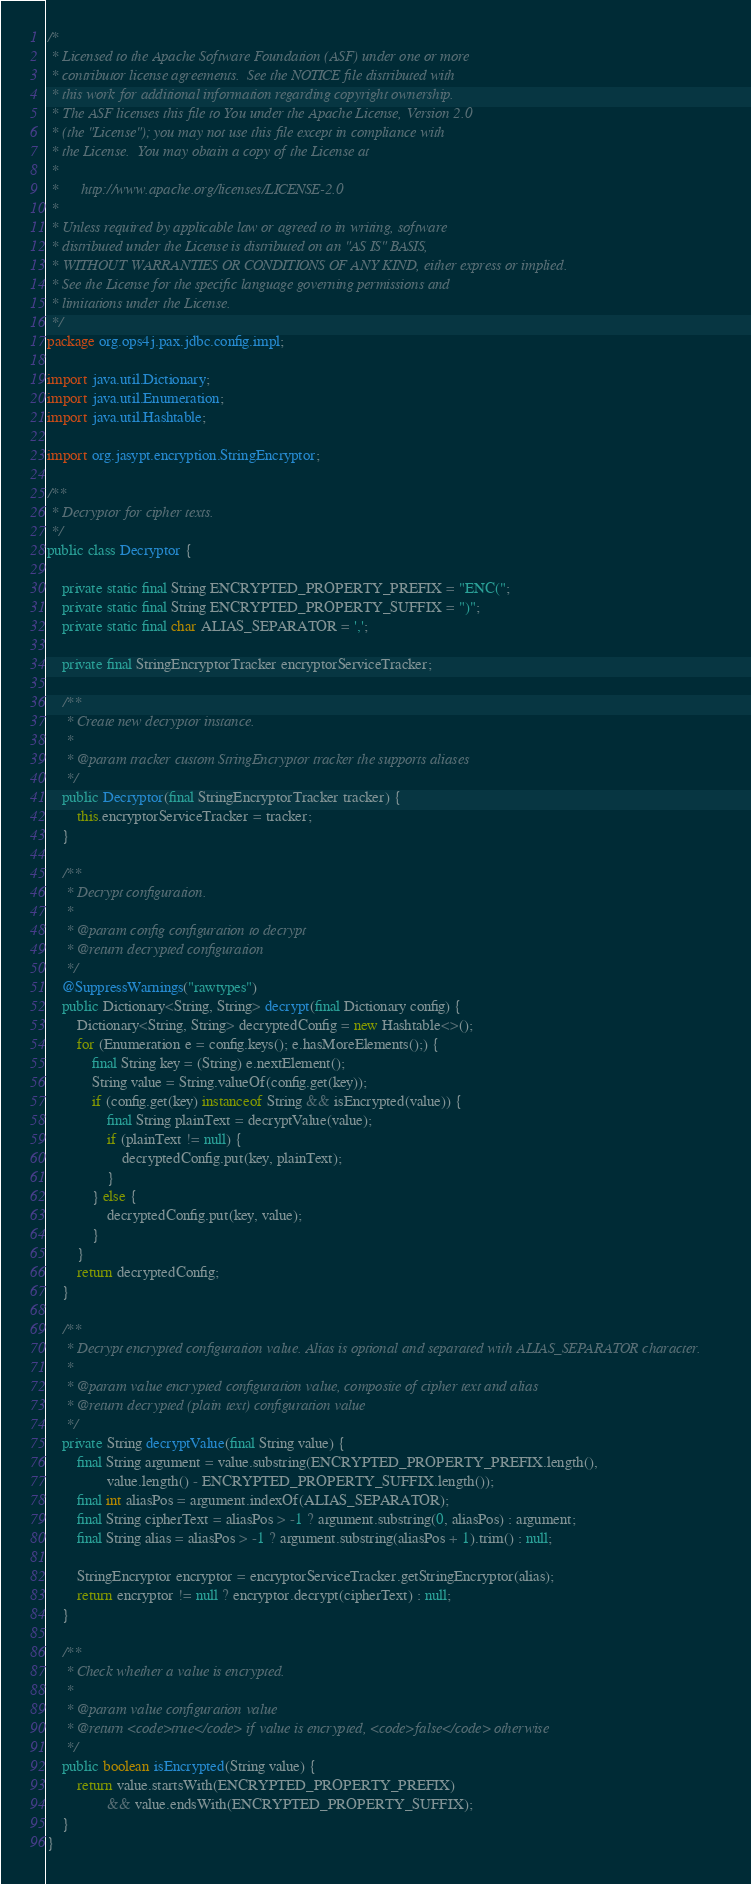<code> <loc_0><loc_0><loc_500><loc_500><_Java_>/*
 * Licensed to the Apache Software Foundation (ASF) under one or more
 * contributor license agreements.  See the NOTICE file distributed with
 * this work for additional information regarding copyright ownership.
 * The ASF licenses this file to You under the Apache License, Version 2.0
 * (the "License"); you may not use this file except in compliance with
 * the License.  You may obtain a copy of the License at
 *
 *      http://www.apache.org/licenses/LICENSE-2.0
 *
 * Unless required by applicable law or agreed to in writing, software
 * distributed under the License is distributed on an "AS IS" BASIS,
 * WITHOUT WARRANTIES OR CONDITIONS OF ANY KIND, either express or implied.
 * See the License for the specific language governing permissions and
 * limitations under the License.
 */
package org.ops4j.pax.jdbc.config.impl;

import java.util.Dictionary;
import java.util.Enumeration;
import java.util.Hashtable;

import org.jasypt.encryption.StringEncryptor;

/**
 * Decryptor for cipher texts.
 */
public class Decryptor {

    private static final String ENCRYPTED_PROPERTY_PREFIX = "ENC(";
    private static final String ENCRYPTED_PROPERTY_SUFFIX = ")";
    private static final char ALIAS_SEPARATOR = ',';

    private final StringEncryptorTracker encryptorServiceTracker;

    /**
     * Create new decryptor instance.
     *
     * @param tracker custom StringEncryptor tracker the supports aliases
     */
    public Decryptor(final StringEncryptorTracker tracker) {
        this.encryptorServiceTracker = tracker;
    }

    /**
     * Decrypt configuration.
     *
     * @param config configuration to decrypt
     * @return decrypted configuration
     */
    @SuppressWarnings("rawtypes")
    public Dictionary<String, String> decrypt(final Dictionary config) {
        Dictionary<String, String> decryptedConfig = new Hashtable<>();
        for (Enumeration e = config.keys(); e.hasMoreElements();) {
            final String key = (String) e.nextElement();
            String value = String.valueOf(config.get(key));
            if (config.get(key) instanceof String && isEncrypted(value)) {
                final String plainText = decryptValue(value);
                if (plainText != null) {
                    decryptedConfig.put(key, plainText);
                }
            } else {
                decryptedConfig.put(key, value);
            }
        }
        return decryptedConfig;
    }

    /**
     * Decrypt encrypted configuration value. Alias is optional and separated with ALIAS_SEPARATOR character.
     *
     * @param value encrypted configuration value, composite of cipher text and alias
     * @return decrypted (plain text) configuration value
     */
    private String decryptValue(final String value) {
        final String argument = value.substring(ENCRYPTED_PROPERTY_PREFIX.length(),
                value.length() - ENCRYPTED_PROPERTY_SUFFIX.length());
        final int aliasPos = argument.indexOf(ALIAS_SEPARATOR);
        final String cipherText = aliasPos > -1 ? argument.substring(0, aliasPos) : argument;
        final String alias = aliasPos > -1 ? argument.substring(aliasPos + 1).trim() : null;

        StringEncryptor encryptor = encryptorServiceTracker.getStringEncryptor(alias);
        return encryptor != null ? encryptor.decrypt(cipherText) : null;
    }

    /**
     * Check whether a value is encrypted.
     *
     * @param value configuration value
     * @return <code>true</code> if value is encrypted, <code>false</code> otherwise
     */
    public boolean isEncrypted(String value) {
        return value.startsWith(ENCRYPTED_PROPERTY_PREFIX)
                && value.endsWith(ENCRYPTED_PROPERTY_SUFFIX);
    }
}
</code> 